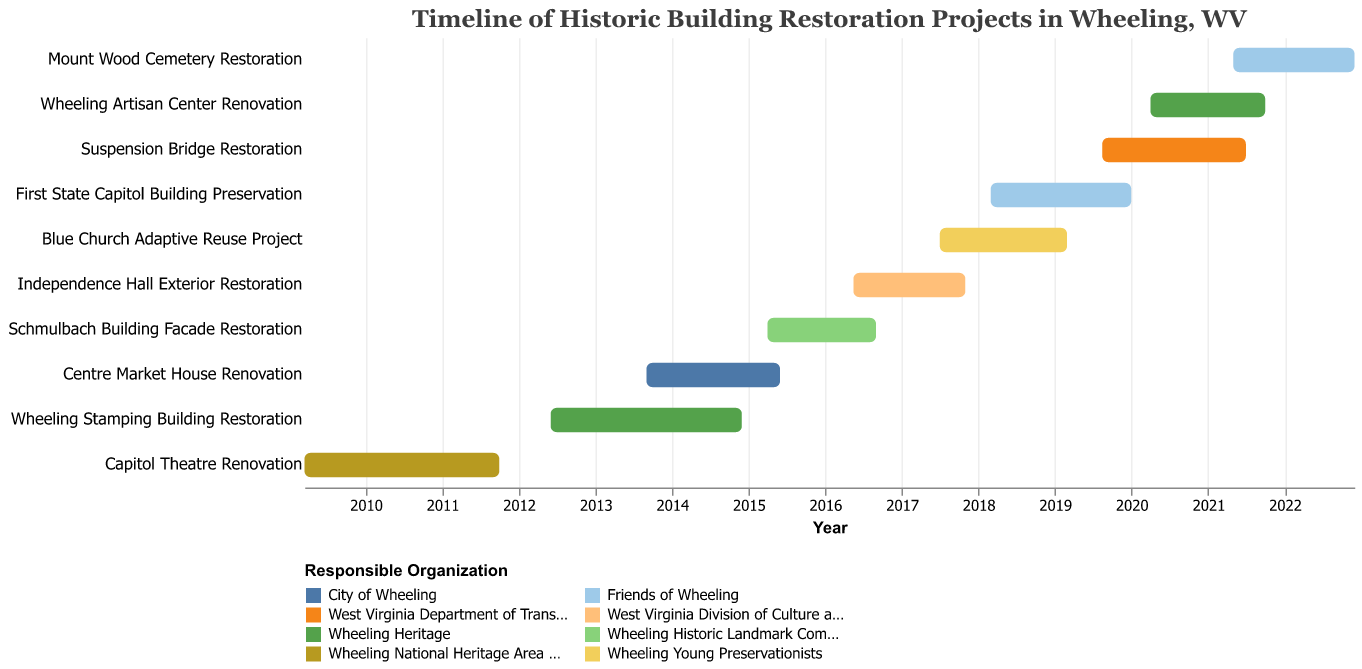Which project started first? The project with the earliest start date is "Capitol Theatre Renovation," which started on March 15, 2009.
Answer: Capitol Theatre Renovation Which organization is responsible for the most projects? By visually counting the projects represented by different colors, we see that "Wheeling Heritage" is responsible for two projects: "Wheeling Stamping Building Restoration" and "Wheeling Artisan Center Renovation."
Answer: Wheeling Heritage Which projects had overlapping timeframes with the "First State Capitol Building Preservation"? The "First State Capitol Building Preservation" project ran from March 1, 2018, to December 31, 2019. During this period, the "Blue Church Adaptive Reuse Project" (July 1, 2017 – February 28, 2019) and "Suspension Bridge Restoration" (August 15, 2019 – June 30, 2021) overlapped with it.
Answer: Blue Church Adaptive Reuse Project, Suspension Bridge Restoration What was the duration of the "Suspension Bridge Restoration" project? The "Suspension Bridge Restoration" project started on August 15, 2019, and ended on June 30, 2021. Calculating the duration involves the months and years in between these dates.
Answer: 1 year and 10.5 months Which project had the shortest duration? By visually comparing the lengths of the bars, the "Schmulbach Building Facade Restoration" project appears to be the shortest, starting on April 1, 2015, and ending on August 31, 2016.
Answer: Schmulbach Building Facade Restoration How many projects were active during 2016? By checking the start and end dates of each project against the year 2016, we find that four projects were active: "Schmulbach Building Facade Restoration" (Jan 2016 – Aug 2016), "Centre Market House Renovation" (Jan 2016 – May 2016), "Independence Hall Exterior Restoration" (May 2016 – Oct 2017), and "First State Capitol Building Preservation" (Mar 2018 – Dec 2019 overlaps part of 2016).
Answer: 3 projects What is the period during which the fewest projects were simultaneously active? Visual inspection of the Gantt chart shows that from late 2022 to early 2023, only one project, "Mount Wood Cemetery Restoration," was active.
Answer: Late 2022 to early 2023 Which organization's projects do not overlap with any others? By visually inspecting the chart, "Friends of Wheeling" do not have overlapping projects; their projects "First State Capitol Building Preservation" (Mar 2018 – Dec 2019) and "Mount Wood Cemetery Restoration" (May 2021 – Nov 2022) only overlap with each other, not with others.
Answer: Friends of Wheeling How many projects were completed in 2018? Projects that ended within the year 2018 are calculated only for two projects: "Independence Hall Exterior Restoration" (ended Oct 2017, not 2018), "First State Capitol Building Preservation" starts in 2018. Only one ends within it.
Answer: One project 